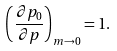Convert formula to latex. <formula><loc_0><loc_0><loc_500><loc_500>\left ( \frac { \partial { p _ { 0 } } } { \partial { p } } \right ) _ { m \rightarrow 0 } = 1 .</formula> 